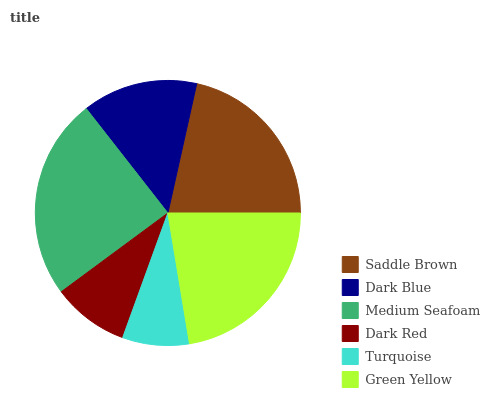Is Turquoise the minimum?
Answer yes or no. Yes. Is Medium Seafoam the maximum?
Answer yes or no. Yes. Is Dark Blue the minimum?
Answer yes or no. No. Is Dark Blue the maximum?
Answer yes or no. No. Is Saddle Brown greater than Dark Blue?
Answer yes or no. Yes. Is Dark Blue less than Saddle Brown?
Answer yes or no. Yes. Is Dark Blue greater than Saddle Brown?
Answer yes or no. No. Is Saddle Brown less than Dark Blue?
Answer yes or no. No. Is Saddle Brown the high median?
Answer yes or no. Yes. Is Dark Blue the low median?
Answer yes or no. Yes. Is Green Yellow the high median?
Answer yes or no. No. Is Turquoise the low median?
Answer yes or no. No. 